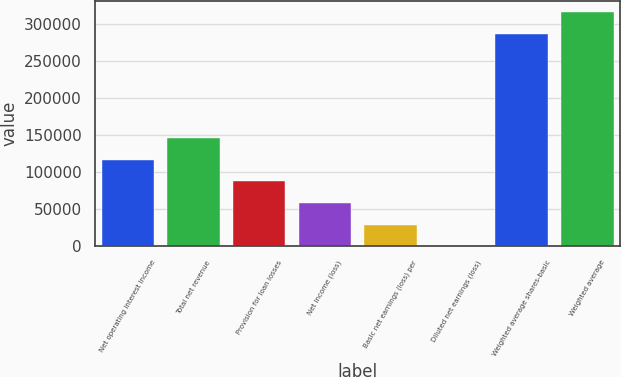<chart> <loc_0><loc_0><loc_500><loc_500><bar_chart><fcel>Net operating interest income<fcel>Total net revenue<fcel>Provision for loan losses<fcel>Net income (loss)<fcel>Basic net earnings (loss) per<fcel>Diluted net earnings (loss)<fcel>Weighted average shares-basic<fcel>Weighted average<nl><fcel>117036<fcel>146295<fcel>87776.9<fcel>58518<fcel>29259.2<fcel>0.29<fcel>286991<fcel>316250<nl></chart> 